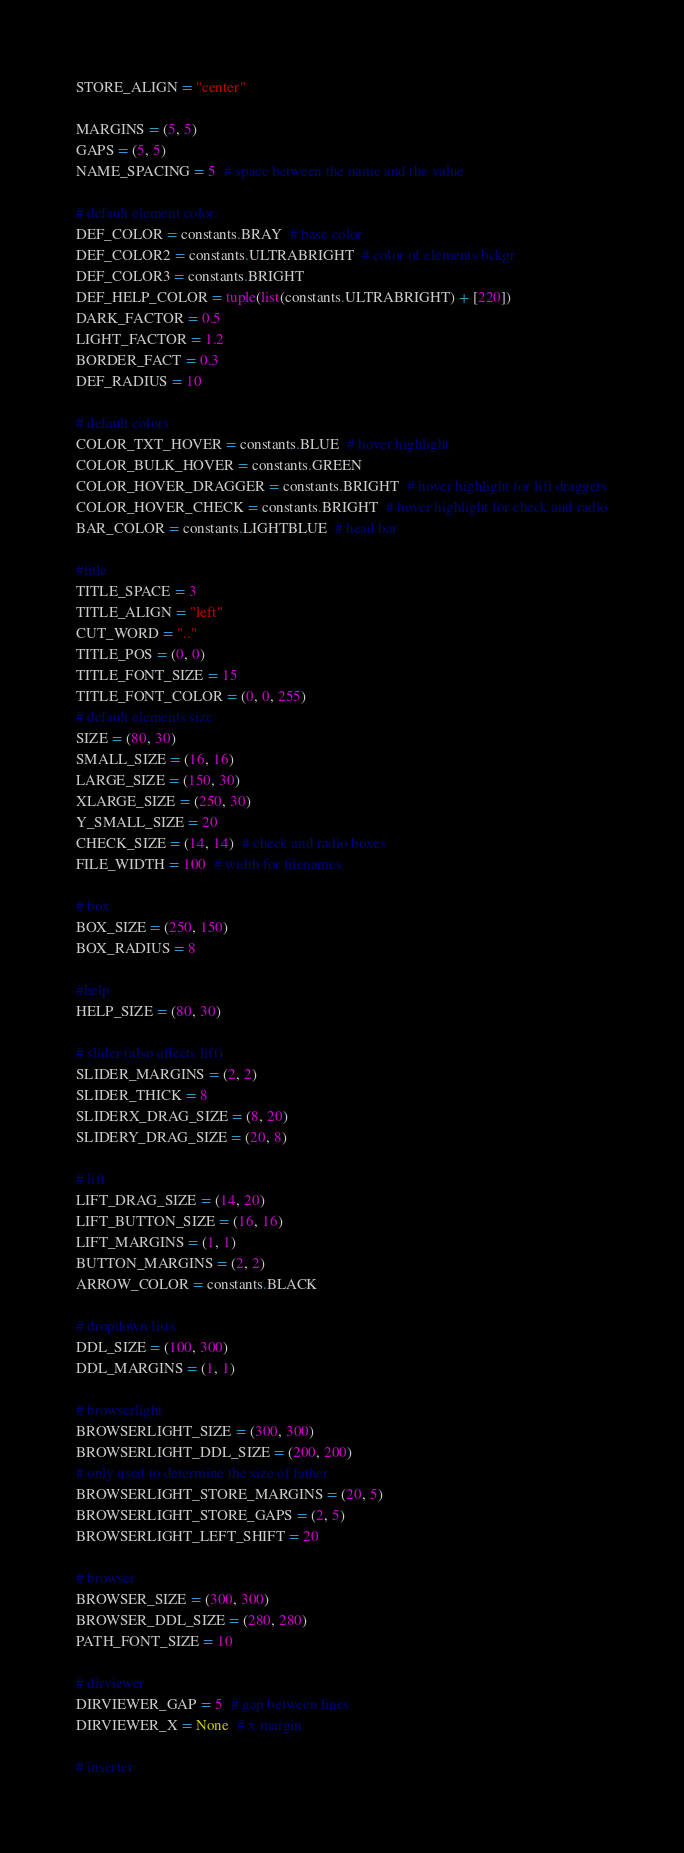Convert code to text. <code><loc_0><loc_0><loc_500><loc_500><_Python_>STORE_ALIGN = "center"

MARGINS = (5, 5)
GAPS = (5, 5)
NAME_SPACING = 5  # space between the name and the value

# default element color:
DEF_COLOR = constants.BRAY  # base color
DEF_COLOR2 = constants.ULTRABRIGHT  # color of elements bckgr
DEF_COLOR3 = constants.BRIGHT
DEF_HELP_COLOR = tuple(list(constants.ULTRABRIGHT) + [220])
DARK_FACTOR = 0.5
LIGHT_FACTOR = 1.2
BORDER_FACT = 0.3
DEF_RADIUS = 10

# default colors
COLOR_TXT_HOVER = constants.BLUE  # hover highlight
COLOR_BULK_HOVER = constants.GREEN
COLOR_HOVER_DRAGGER = constants.BRIGHT  # hover highlight for lift draggers
COLOR_HOVER_CHECK = constants.BRIGHT  # hover highlight for check and radio
BAR_COLOR = constants.LIGHTBLUE  # head bar

#title
TITLE_SPACE = 3
TITLE_ALIGN = "left"
CUT_WORD = ".."
TITLE_POS = (0, 0)
TITLE_FONT_SIZE = 15
TITLE_FONT_COLOR = (0, 0, 255)
# default elements size
SIZE = (80, 30)
SMALL_SIZE = (16, 16)
LARGE_SIZE = (150, 30)
XLARGE_SIZE = (250, 30)
Y_SMALL_SIZE = 20
CHECK_SIZE = (14, 14)  # check and radio boxes
FILE_WIDTH = 100  # width for filenames

# box
BOX_SIZE = (250, 150)
BOX_RADIUS = 8

#help
HELP_SIZE = (80, 30)

# slider (also affects lift)
SLIDER_MARGINS = (2, 2)
SLIDER_THICK = 8
SLIDERX_DRAG_SIZE = (8, 20)
SLIDERY_DRAG_SIZE = (20, 8)

# lift
LIFT_DRAG_SIZE = (14, 20)
LIFT_BUTTON_SIZE = (16, 16)
LIFT_MARGINS = (1, 1)
BUTTON_MARGINS = (2, 2)
ARROW_COLOR = constants.BLACK

# dropdown lists
DDL_SIZE = (100, 300)
DDL_MARGINS = (1, 1)

# browserlight
BROWSERLIGHT_SIZE = (300, 300)
BROWSERLIGHT_DDL_SIZE = (200, 200)
# only used to determine the size of father
BROWSERLIGHT_STORE_MARGINS = (20, 5)
BROWSERLIGHT_STORE_GAPS = (2, 5)
BROWSERLIGHT_LEFT_SHIFT = 20

# browser
BROWSER_SIZE = (300, 300)
BROWSER_DDL_SIZE = (280, 280)
PATH_FONT_SIZE = 10

# dirviewer
DIRVIEWER_GAP = 5  # gap between lines
DIRVIEWER_X = None  # x margin

# inserter</code> 